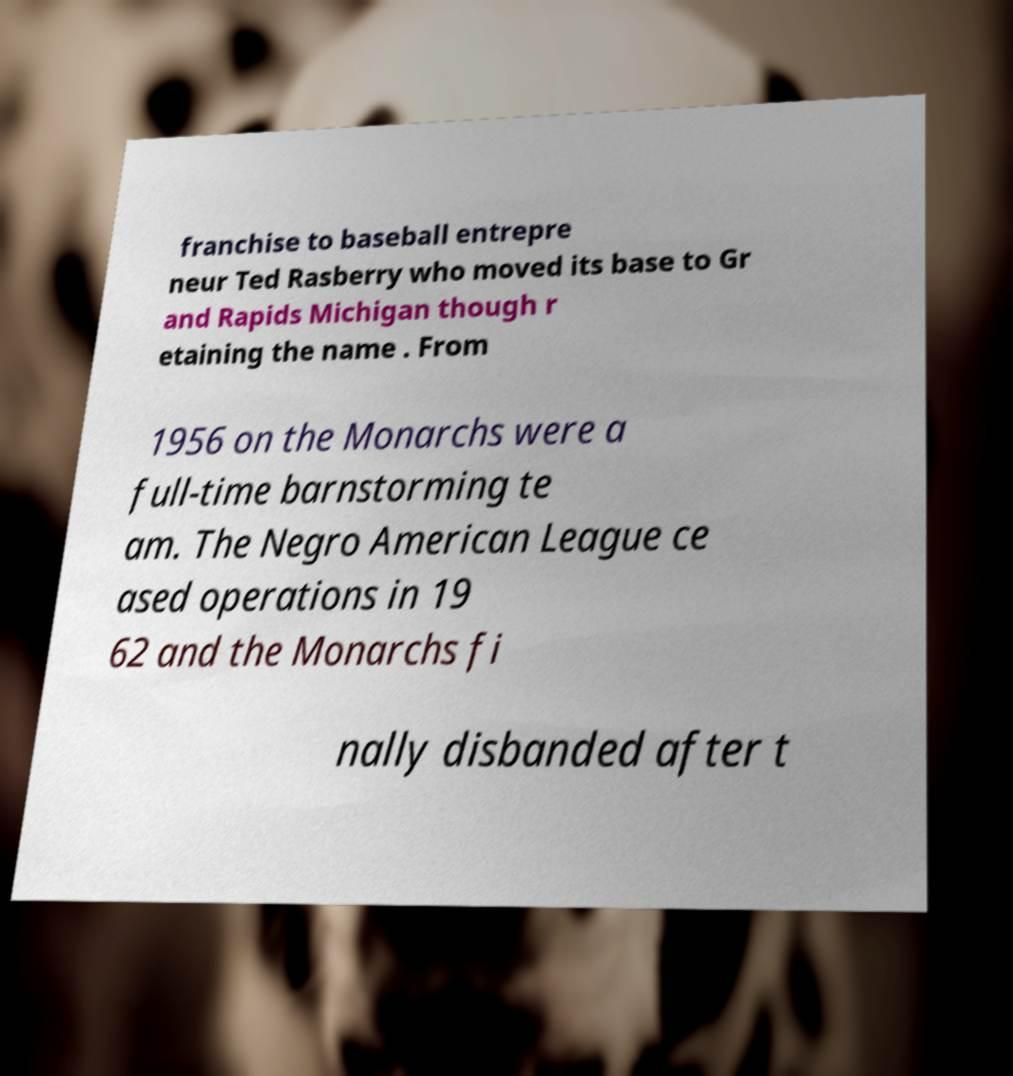I need the written content from this picture converted into text. Can you do that? franchise to baseball entrepre neur Ted Rasberry who moved its base to Gr and Rapids Michigan though r etaining the name . From 1956 on the Monarchs were a full-time barnstorming te am. The Negro American League ce ased operations in 19 62 and the Monarchs fi nally disbanded after t 